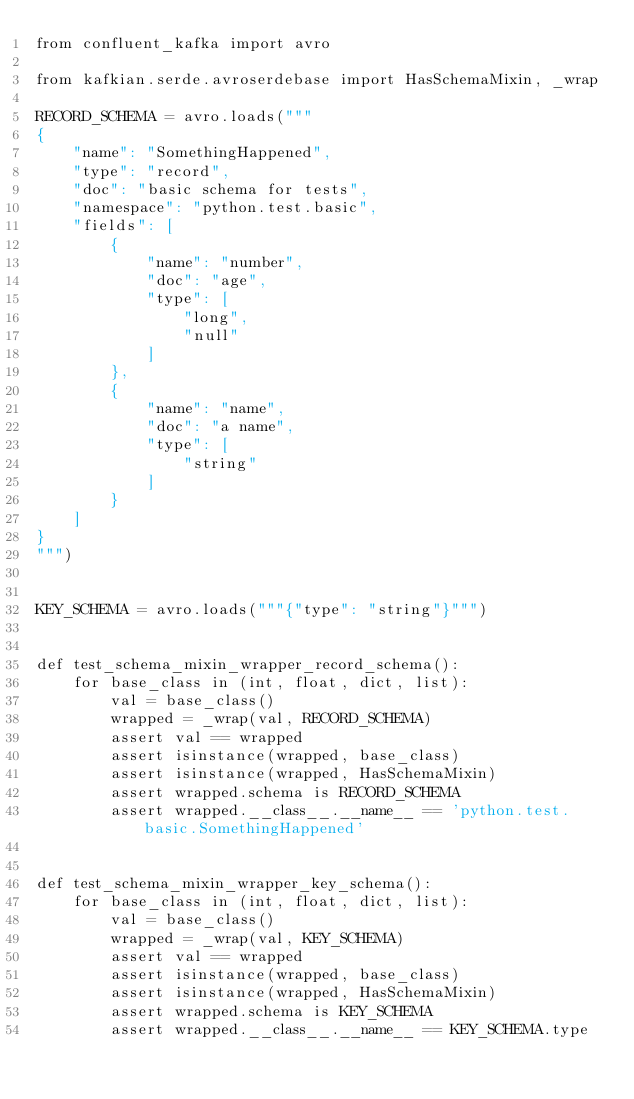<code> <loc_0><loc_0><loc_500><loc_500><_Python_>from confluent_kafka import avro

from kafkian.serde.avroserdebase import HasSchemaMixin, _wrap

RECORD_SCHEMA = avro.loads("""
{
    "name": "SomethingHappened",
    "type": "record",
    "doc": "basic schema for tests",
    "namespace": "python.test.basic",
    "fields": [
        {
            "name": "number",
            "doc": "age",
            "type": [
                "long",
                "null"
            ]
        },
        {
            "name": "name",
            "doc": "a name",
            "type": [
                "string"
            ]
        }
    ]
}
""")


KEY_SCHEMA = avro.loads("""{"type": "string"}""")


def test_schema_mixin_wrapper_record_schema():
    for base_class in (int, float, dict, list):
        val = base_class()
        wrapped = _wrap(val, RECORD_SCHEMA)
        assert val == wrapped
        assert isinstance(wrapped, base_class)
        assert isinstance(wrapped, HasSchemaMixin)
        assert wrapped.schema is RECORD_SCHEMA
        assert wrapped.__class__.__name__ == 'python.test.basic.SomethingHappened'


def test_schema_mixin_wrapper_key_schema():
    for base_class in (int, float, dict, list):
        val = base_class()
        wrapped = _wrap(val, KEY_SCHEMA)
        assert val == wrapped
        assert isinstance(wrapped, base_class)
        assert isinstance(wrapped, HasSchemaMixin)
        assert wrapped.schema is KEY_SCHEMA
        assert wrapped.__class__.__name__ == KEY_SCHEMA.type
</code> 